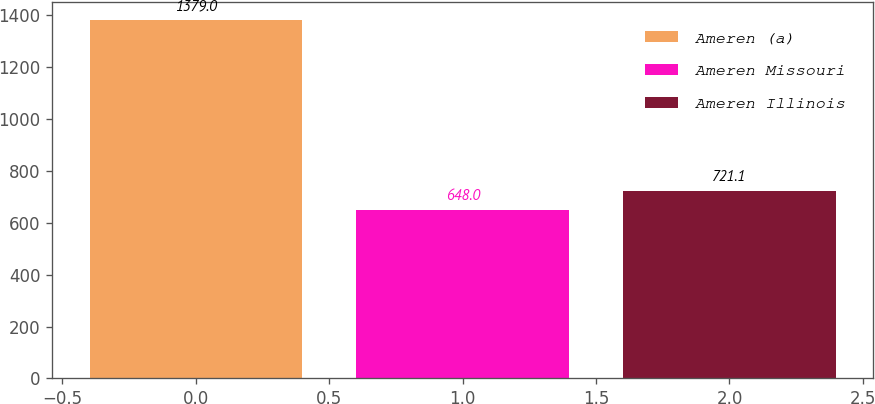Convert chart to OTSL. <chart><loc_0><loc_0><loc_500><loc_500><bar_chart><fcel>Ameren (a)<fcel>Ameren Missouri<fcel>Ameren Illinois<nl><fcel>1379<fcel>648<fcel>721.1<nl></chart> 